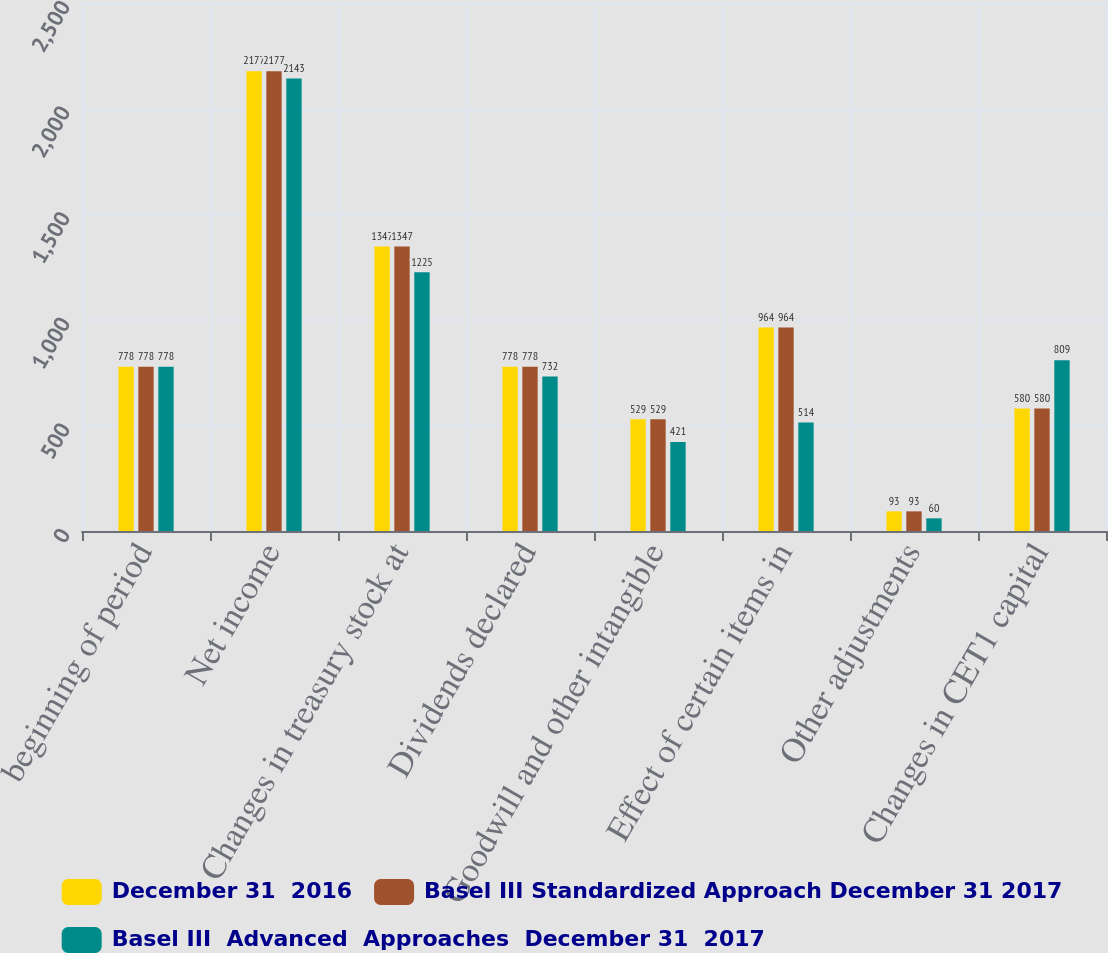<chart> <loc_0><loc_0><loc_500><loc_500><stacked_bar_chart><ecel><fcel>beginning of period<fcel>Net income<fcel>Changes in treasury stock at<fcel>Dividends declared<fcel>Goodwill and other intangible<fcel>Effect of certain items in<fcel>Other adjustments<fcel>Changes in CET1 capital<nl><fcel>December 31  2016<fcel>778<fcel>2177<fcel>1347<fcel>778<fcel>529<fcel>964<fcel>93<fcel>580<nl><fcel>Basel III Standardized Approach December 31 2017<fcel>778<fcel>2177<fcel>1347<fcel>778<fcel>529<fcel>964<fcel>93<fcel>580<nl><fcel>Basel III  Advanced  Approaches  December 31  2017<fcel>778<fcel>2143<fcel>1225<fcel>732<fcel>421<fcel>514<fcel>60<fcel>809<nl></chart> 